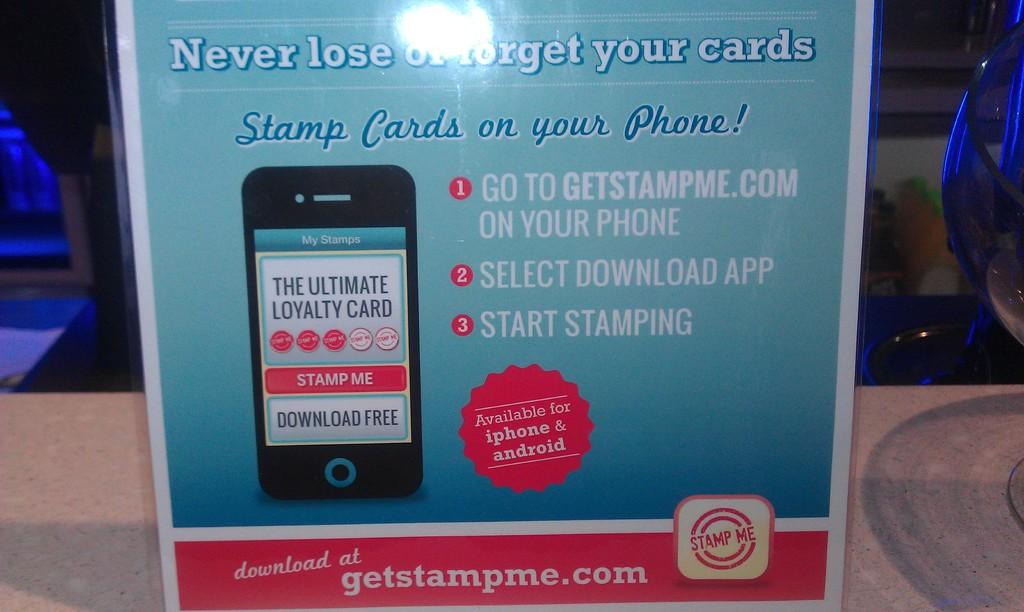<image>
Give a short and clear explanation of the subsequent image. an advertisement on stamp cards that is red and blue 